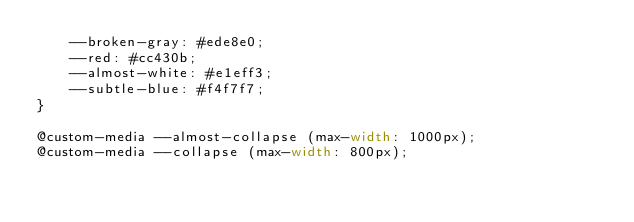<code> <loc_0><loc_0><loc_500><loc_500><_CSS_>    --broken-gray: #ede8e0;
    --red: #cc430b;
    --almost-white: #e1eff3;
    --subtle-blue: #f4f7f7;
}

@custom-media --almost-collapse (max-width: 1000px);
@custom-media --collapse (max-width: 800px);
</code> 